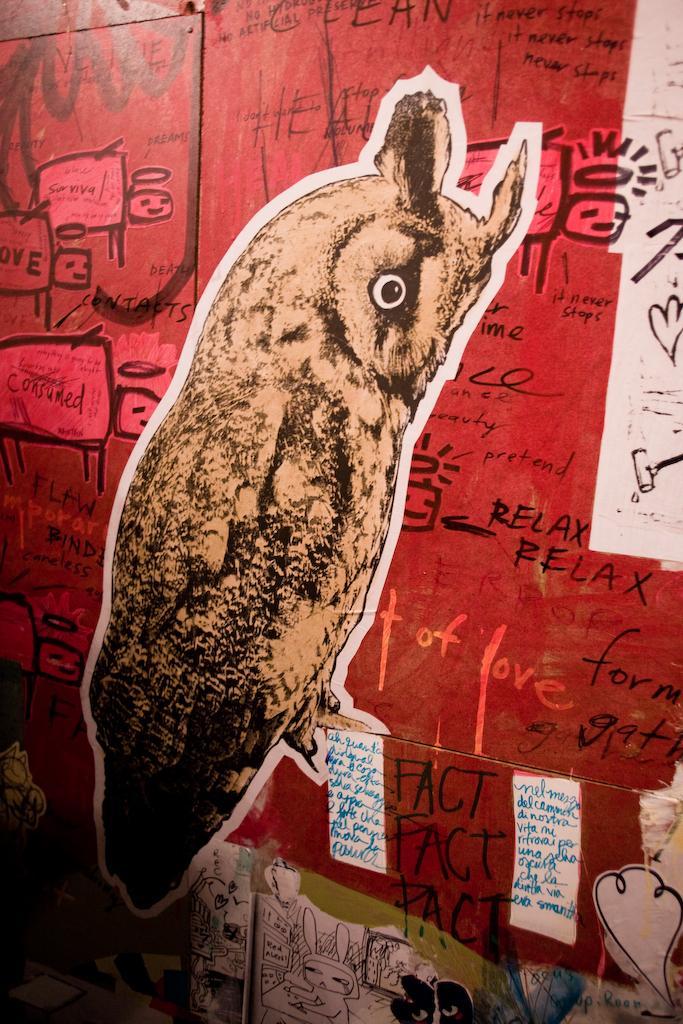Describe this image in one or two sentences. In this picture we can see posts, here we can see an animal, some text and some objects on it. 